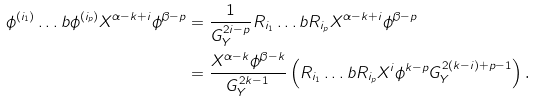Convert formula to latex. <formula><loc_0><loc_0><loc_500><loc_500>\phi ^ { ( i _ { 1 } ) } \dots b \phi ^ { ( i _ { p } ) } X ^ { \alpha - k + i } \phi ^ { \beta - p } & = \frac { 1 } { G _ { Y } ^ { 2 i - p } } R _ { i _ { 1 } } \dots b R _ { i _ { p } } X ^ { \alpha - k + i } \phi ^ { \beta - p } \\ & = \frac { X ^ { \alpha - k } \phi ^ { \beta - k } } { G _ { Y } ^ { 2 k - 1 } } \left ( R _ { i _ { 1 } } \dots b R _ { i _ { p } } X ^ { i } \phi ^ { k - p } G _ { Y } ^ { 2 ( k - i ) + p - 1 } \right ) \text  .</formula> 